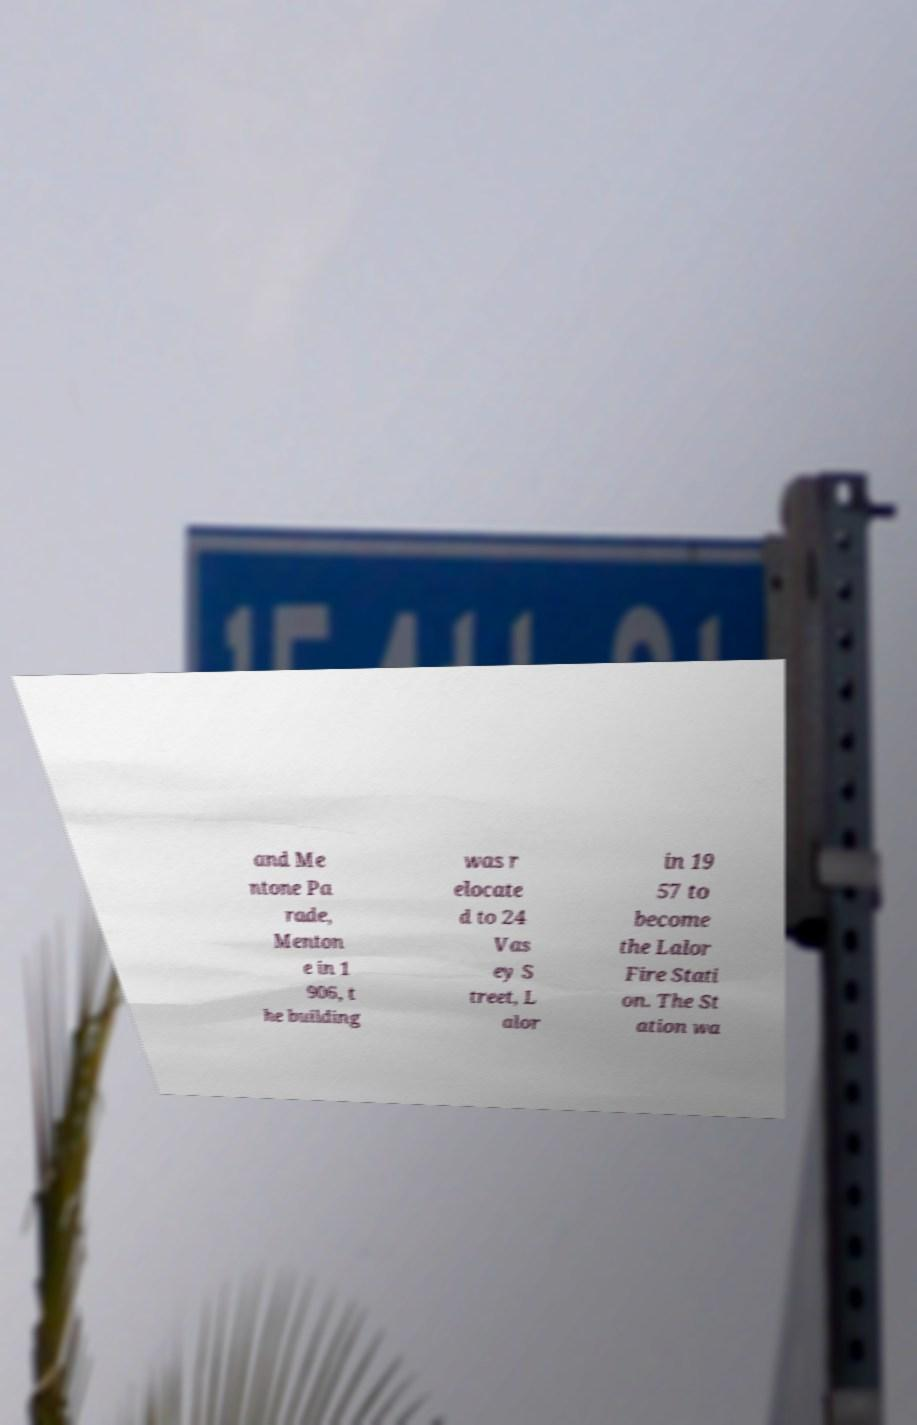Could you assist in decoding the text presented in this image and type it out clearly? and Me ntone Pa rade, Menton e in 1 906, t he building was r elocate d to 24 Vas ey S treet, L alor in 19 57 to become the Lalor Fire Stati on. The St ation wa 